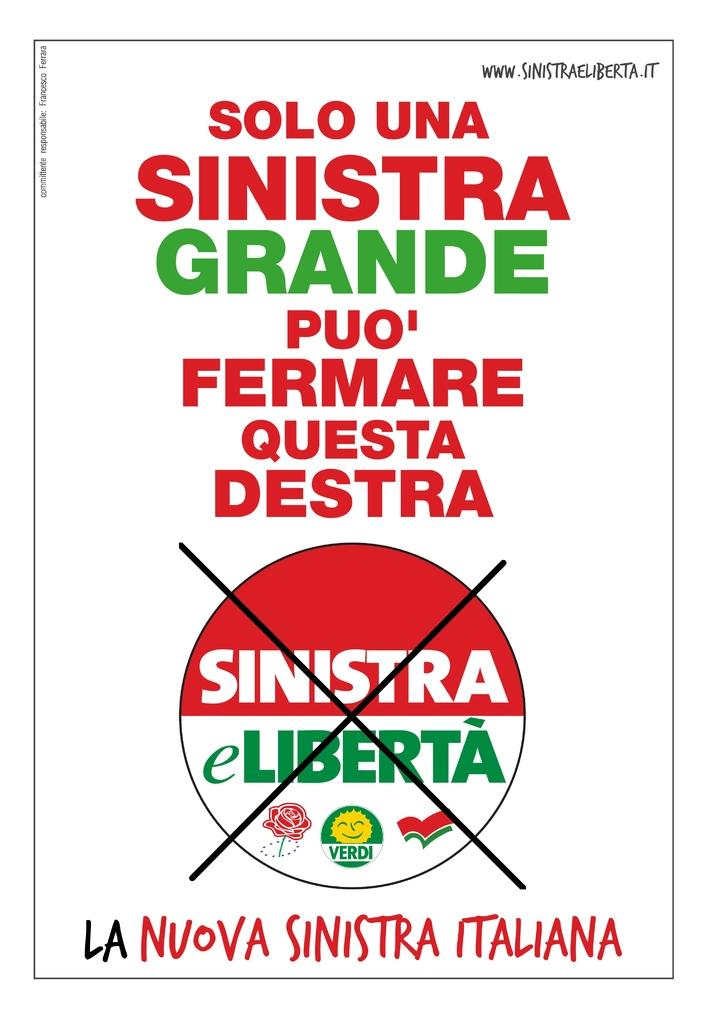<image>
Offer a succinct explanation of the picture presented. Billboard sign that says Solo Una Sinistra Grande Puo'Fermare Questa Destra, La Nuova, Sinistra Italiana. 